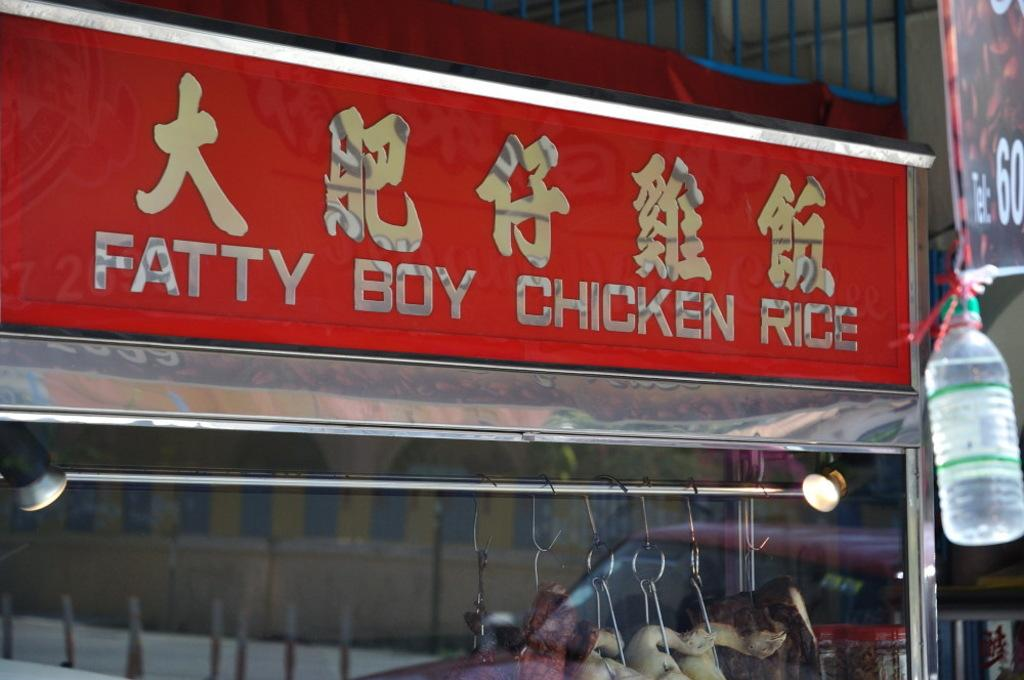Provide a one-sentence caption for the provided image. A restaurant sign that says Fatty Boy Chicken Rice. 